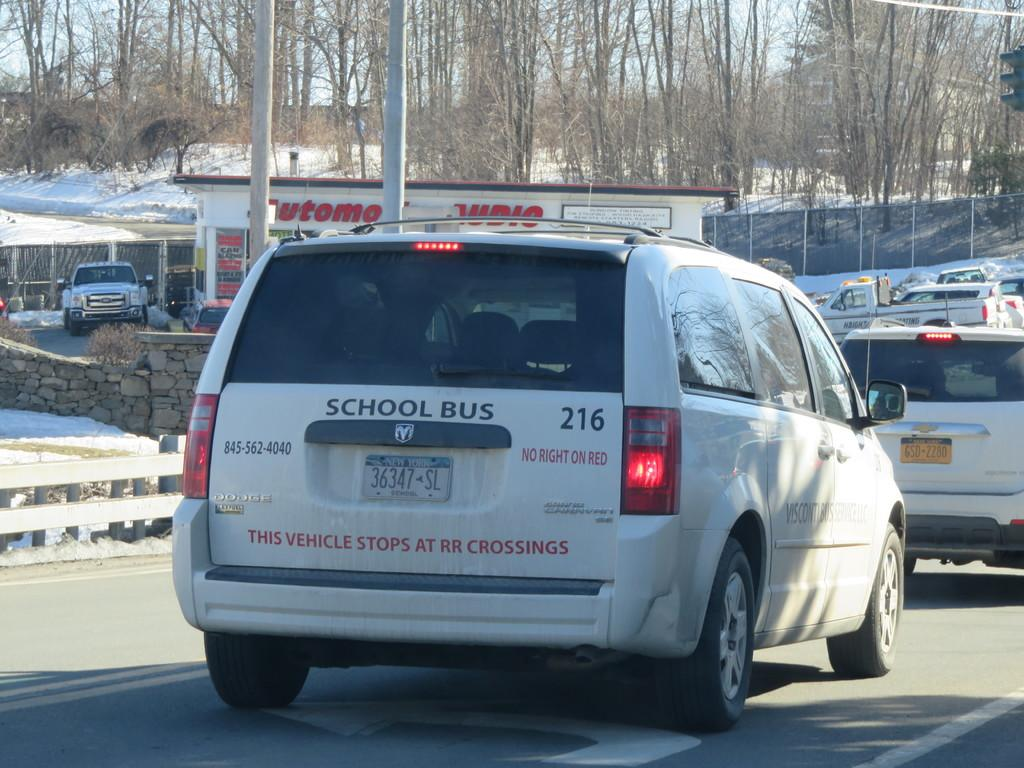What can be seen on the road in the image? There are vehicles on the road in the image. What type of structure is present in the image? There is a shed and a building in the image. What is used to enclose or separate areas in the image? There is a fence in the image. What type of vegetation is present in the image? There are trees in the image. What is visible in the background of the image? The sky is visible in the background of the image. What type of paste is being used to decorate the building in the image? There is no paste or decoration mentioned in the image; it only shows vehicles on the road, a shed, a building, a fence, trees, and the sky. How many bells can be heard ringing in the image? There are no bells or sounds mentioned in the image; it only shows visual elements. 